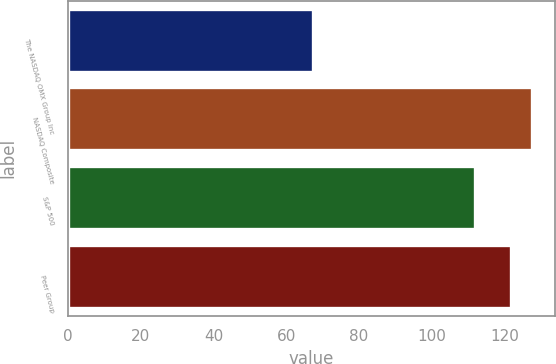Convert chart to OTSL. <chart><loc_0><loc_0><loc_500><loc_500><bar_chart><fcel>The NASDAQ OMX Group Inc<fcel>NASDAQ Composite<fcel>S&P 500<fcel>Peer Group<nl><fcel>67.45<fcel>127.52<fcel>111.99<fcel>121.67<nl></chart> 